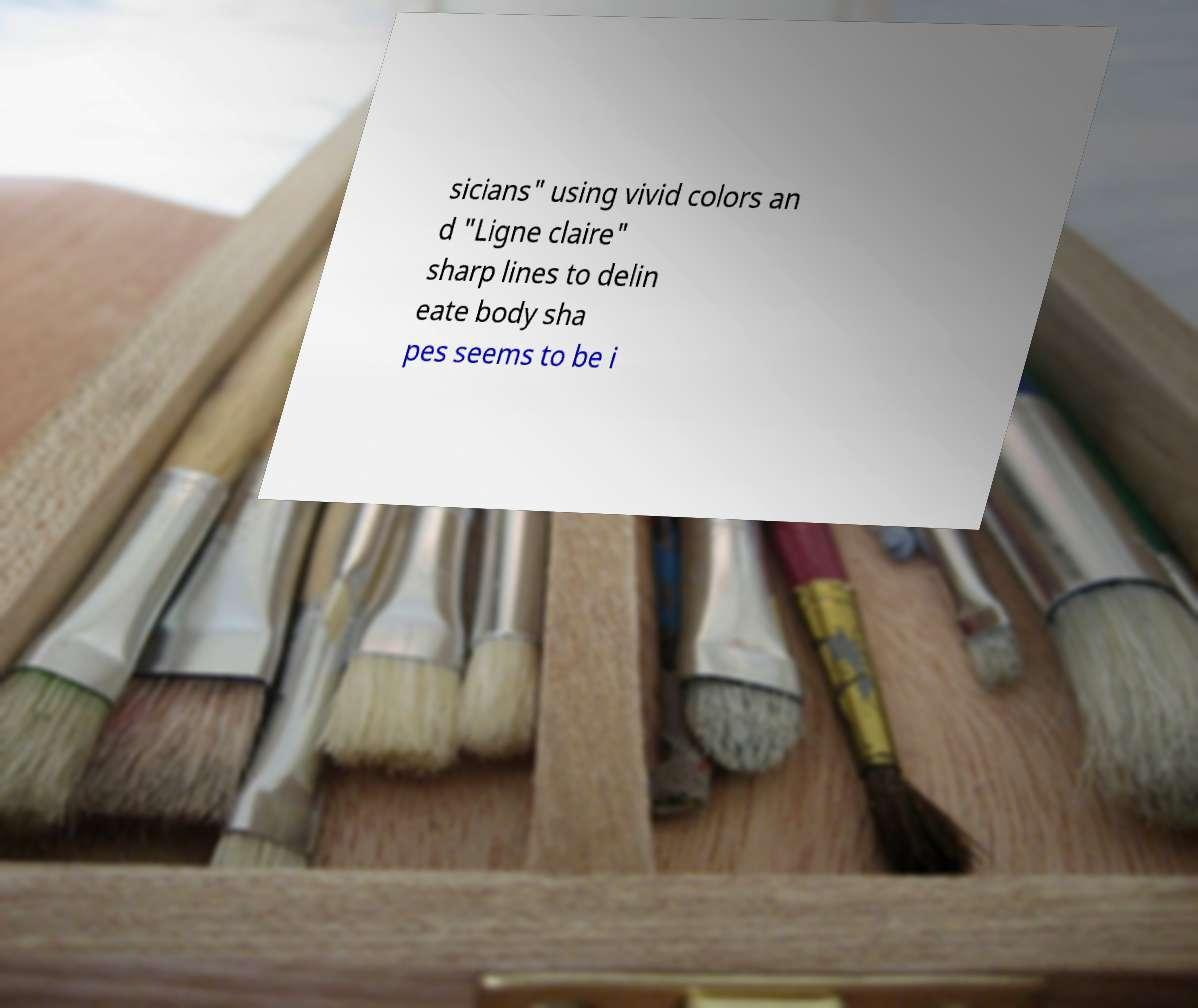Can you read and provide the text displayed in the image?This photo seems to have some interesting text. Can you extract and type it out for me? sicians" using vivid colors an d "Ligne claire" sharp lines to delin eate body sha pes seems to be i 